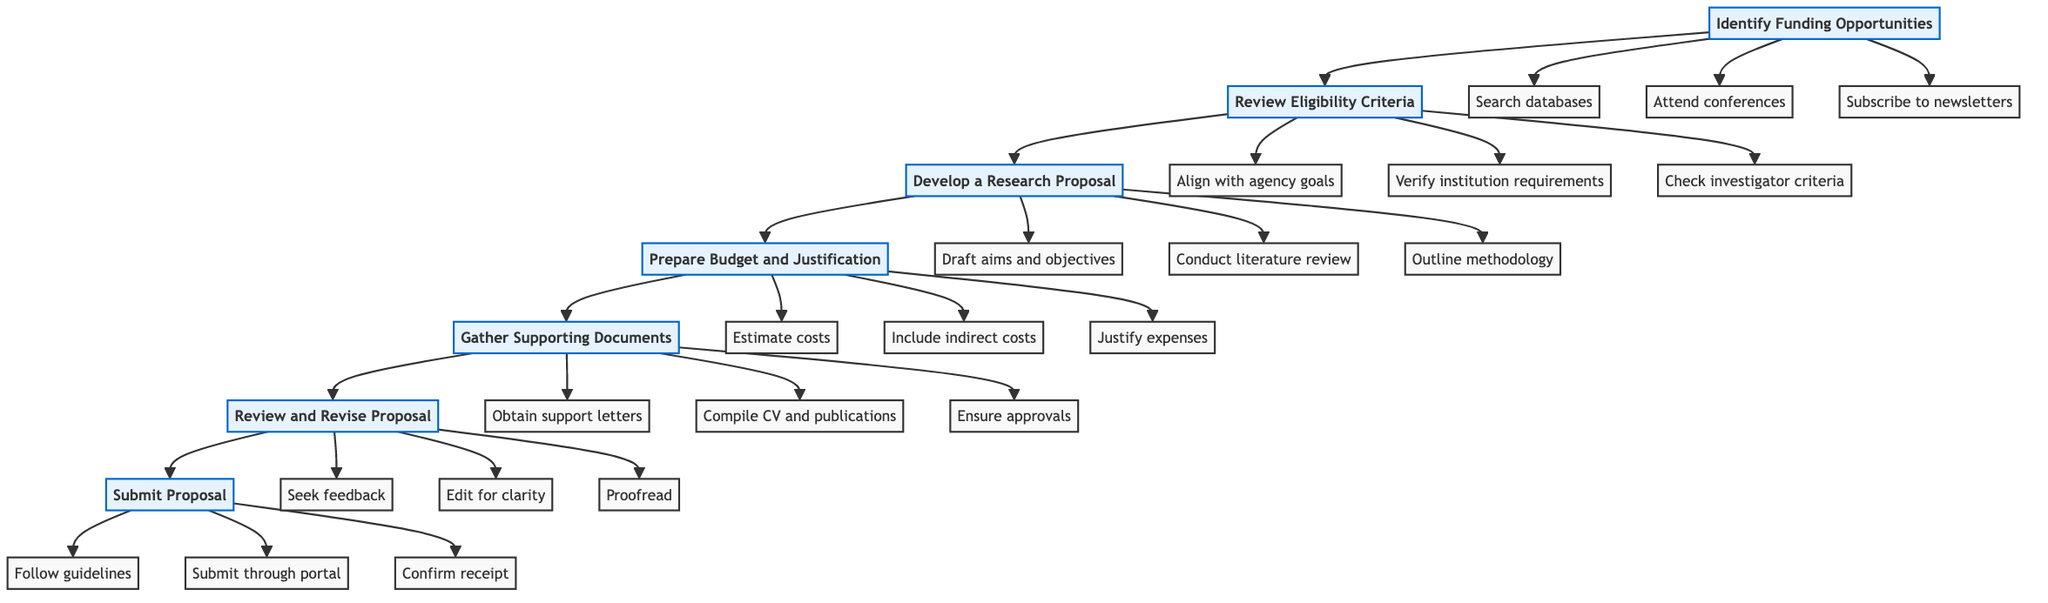What is the first step in the grant application process? The first step in the flowchart indicates that the initial action to be taken is to "Identify Funding Opportunities".
Answer: Identify Funding Opportunities How many main steps are there in the diagram? By counting the main nodes representing the steps in the flowchart, there are a total of seven main steps listed from identification to submission.
Answer: 7 Which step follows the "Review Eligibility Criteria"? The flowchart shows that the next step after "Review Eligibility Criteria" is "Develop a Research Proposal".
Answer: Develop a Research Proposal What type of documents should be gathered in the fifth step? According to the information in the diagram, the focus of the fifth step is on "Supporting Documents", which specifically involves obtaining letters of support, compiling a CV, and ensuring approvals.
Answer: Supporting Documents What is the last action you should take after preparing your proposal? The flowchart clearly indicates that the final action to take is to "Submit Proposal".
Answer: Submit Proposal What are two tasks involved in the "Prepare Budget and Justification" step? Looking at the details under this step in the diagram, two specific tasks mentioned are "Estimate costs for personnel, equipment, and supplies" and "Include indirect costs as required by your institution".
Answer: Estimate costs, Include indirect costs How do you ensure that your research proposal aligns with the funding agency's goals? The diagram specifies that to ensure this alignment, you should "Check for specific investigator criteria", which involves confirming that your research matches the goals set by the agency.
Answer: Align with agency goals What is the purpose of seeking feedback in the "Review and Revise Proposal" step? The flowchart indicates that one of the goals of seeking feedback is for improving the proposal by "looking for input from colleagues and mentors", which will enhance clarity and effectiveness.
Answer: Improve proposal What is required before submitting a proposal related to human subjects? The diagram mentions that obtaining "IRB or IACUC approvals" is necessary if the research involves human or animal subjects before submission.
Answer: IRB or IACUC approvals 